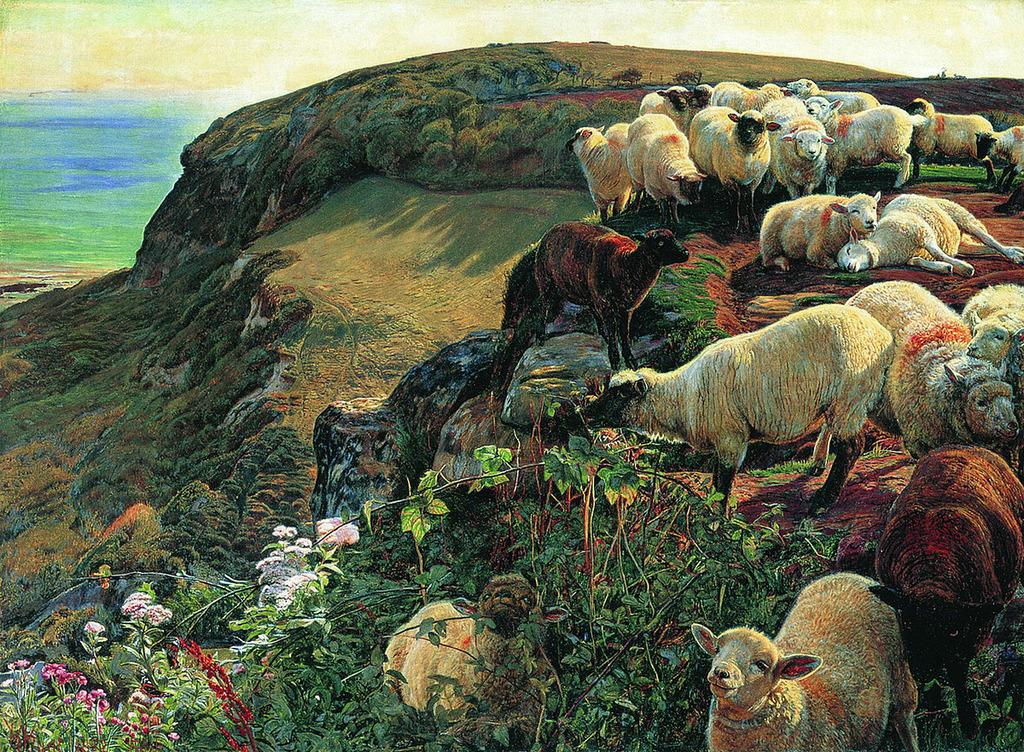What type of living organisms can be seen in the image? There are animals in the image. Can you describe the color of the animals? The animals are in brown and cream color. What else is present in the image besides the animals? There are plants in the image. What color are the flowers on the plants? The flowers on the plants are in pink and white color. What can be seen in the background of the image? The sky is visible in the background of the image. What type of wrist support is visible in the image? There is no wrist support present in the image. How many bulbs are illuminated in the image? There are no bulbs present in the image. 